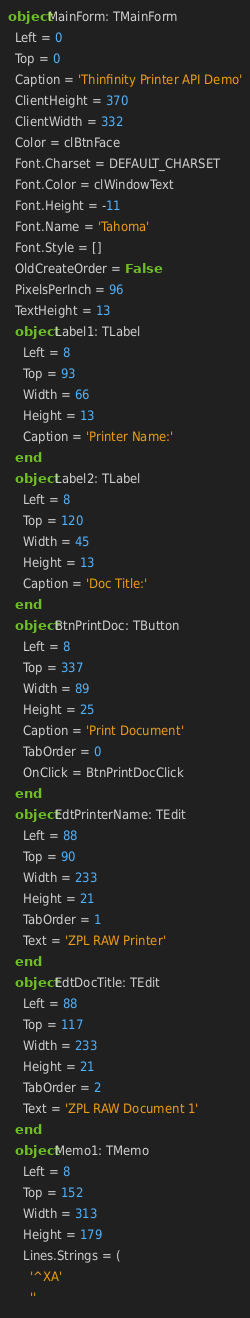Convert code to text. <code><loc_0><loc_0><loc_500><loc_500><_Pascal_>object MainForm: TMainForm
  Left = 0
  Top = 0
  Caption = 'Thinfinity Printer API Demo'
  ClientHeight = 370
  ClientWidth = 332
  Color = clBtnFace
  Font.Charset = DEFAULT_CHARSET
  Font.Color = clWindowText
  Font.Height = -11
  Font.Name = 'Tahoma'
  Font.Style = []
  OldCreateOrder = False
  PixelsPerInch = 96
  TextHeight = 13
  object Label1: TLabel
    Left = 8
    Top = 93
    Width = 66
    Height = 13
    Caption = 'Printer Name:'
  end
  object Label2: TLabel
    Left = 8
    Top = 120
    Width = 45
    Height = 13
    Caption = 'Doc Title:'
  end
  object BtnPrintDoc: TButton
    Left = 8
    Top = 337
    Width = 89
    Height = 25
    Caption = 'Print Document'
    TabOrder = 0
    OnClick = BtnPrintDocClick
  end
  object EdtPrinterName: TEdit
    Left = 88
    Top = 90
    Width = 233
    Height = 21
    TabOrder = 1
    Text = 'ZPL RAW Printer'
  end
  object EdtDocTitle: TEdit
    Left = 88
    Top = 117
    Width = 233
    Height = 21
    TabOrder = 2
    Text = 'ZPL RAW Document 1'
  end
  object Memo1: TMemo
    Left = 8
    Top = 152
    Width = 313
    Height = 179
    Lines.Strings = (
      '^XA'
      ''</code> 